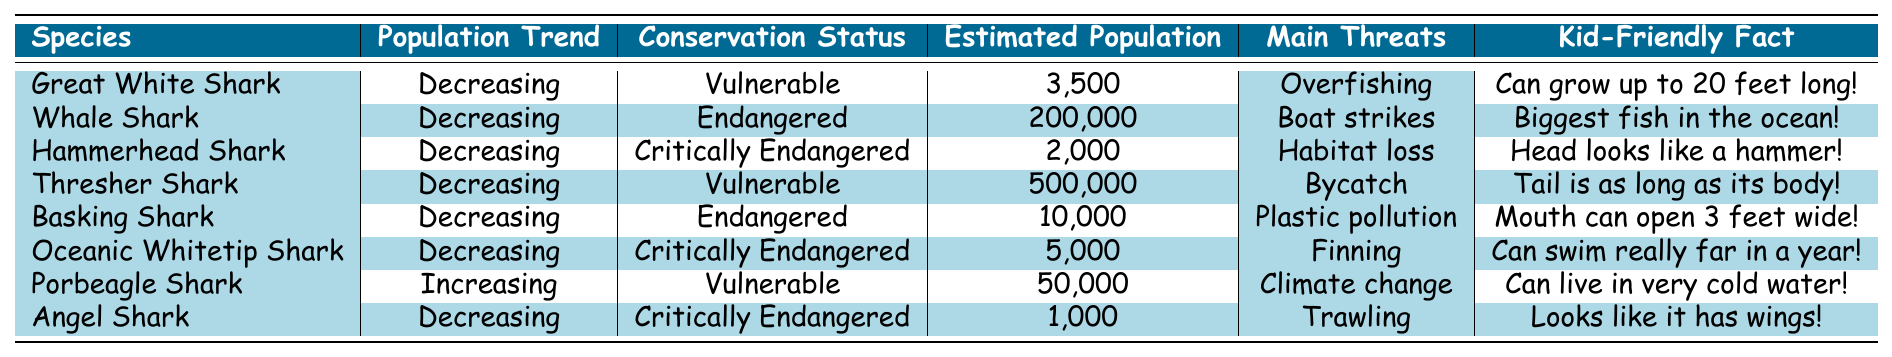What is the estimated population of the Whale Shark? The table lists the estimated population of the Whale Shark as 200,000.
Answer: 200,000 Which shark species has the highest estimated population? By comparing the estimated populations in the table, the Thresher Shark has the highest population at 500,000.
Answer: Thresher Shark Are there any shark species that have an increasing population trend? The table indicates that the Porbeagle Shark is the only species listed with an increasing population trend.
Answer: Yes What are the main threats faced by the Hammerhead Shark? The table shows that the main threats to the Hammerhead Shark are habitat loss.
Answer: Habitat loss Which species is classified as critically endangered and has the lowest estimated population? The Angel Shark is critically endangered and has the lowest estimated population of 1,000.
Answer: Angel Shark How many species listed are classified as endangered? The Basking Shark and the Whale Shark are both classified as endangered, totaling two species.
Answer: 2 What is the total estimated population of all shark species mentioned in the table? Adding the estimated populations of all species: 3500 + 200000 + 2000 + 500000 + 10000 + 5000 + 50000 + 1000 = 760,500.
Answer: 760,500 Which shark species has the fact that it "can swim really far in a year"? According to the table, the Oceanic Whitetip Shark has the fact that it "can swim really far in a year."
Answer: Oceanic Whitetip Shark Are all shark species' populations decreasing? No, only the Porbeagle Shark has an increasing population trend while others are decreasing.
Answer: No What is the main threat to Basking Sharks according to the table? The main threat to Basking Sharks, as per the table, is plastic pollution.
Answer: Plastic pollution 